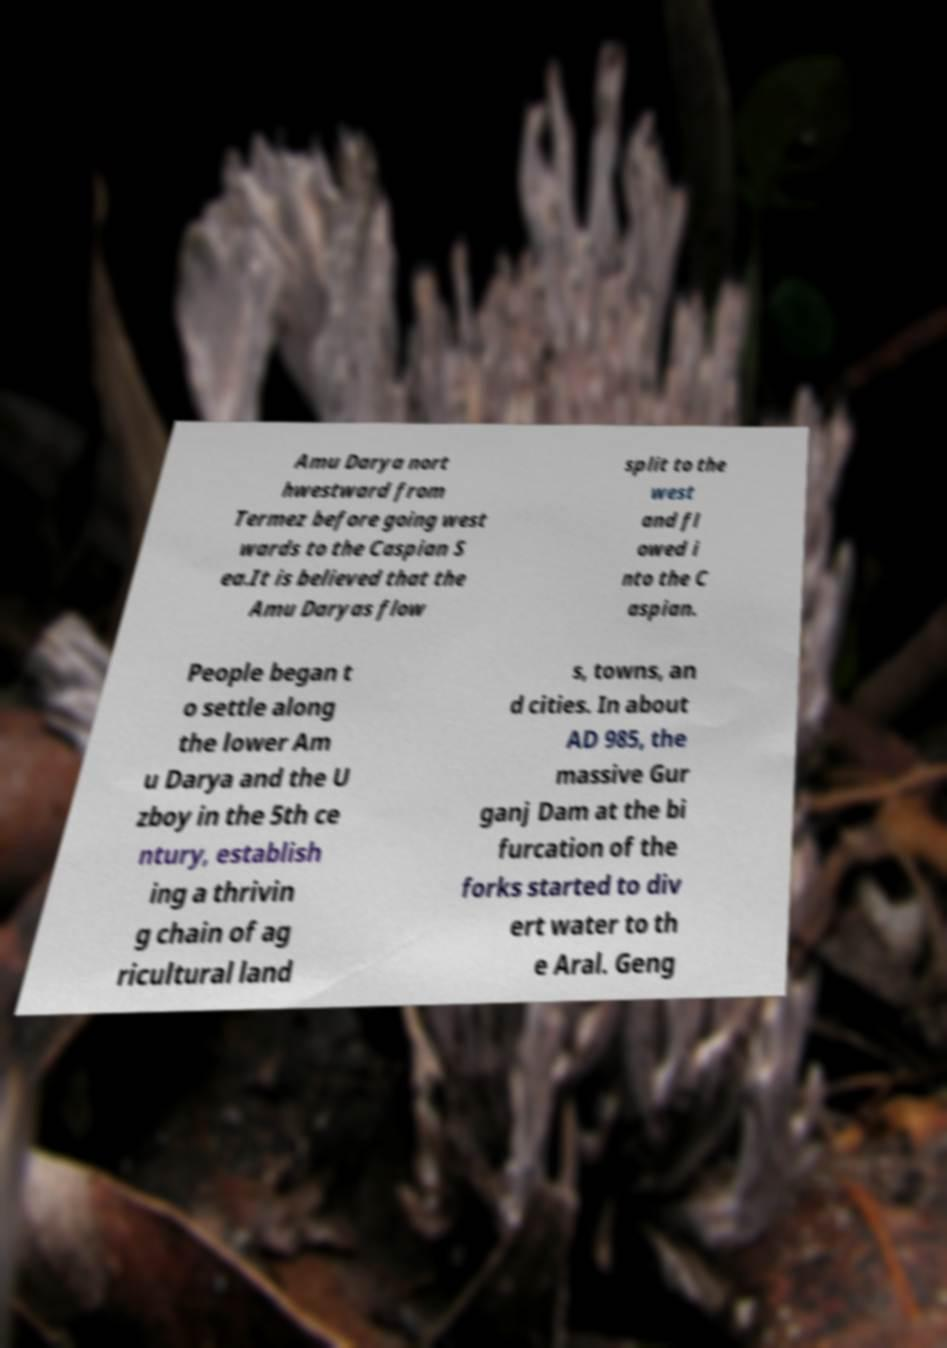Please identify and transcribe the text found in this image. Amu Darya nort hwestward from Termez before going west wards to the Caspian S ea.It is believed that the Amu Daryas flow split to the west and fl owed i nto the C aspian. People began t o settle along the lower Am u Darya and the U zboy in the 5th ce ntury, establish ing a thrivin g chain of ag ricultural land s, towns, an d cities. In about AD 985, the massive Gur ganj Dam at the bi furcation of the forks started to div ert water to th e Aral. Geng 